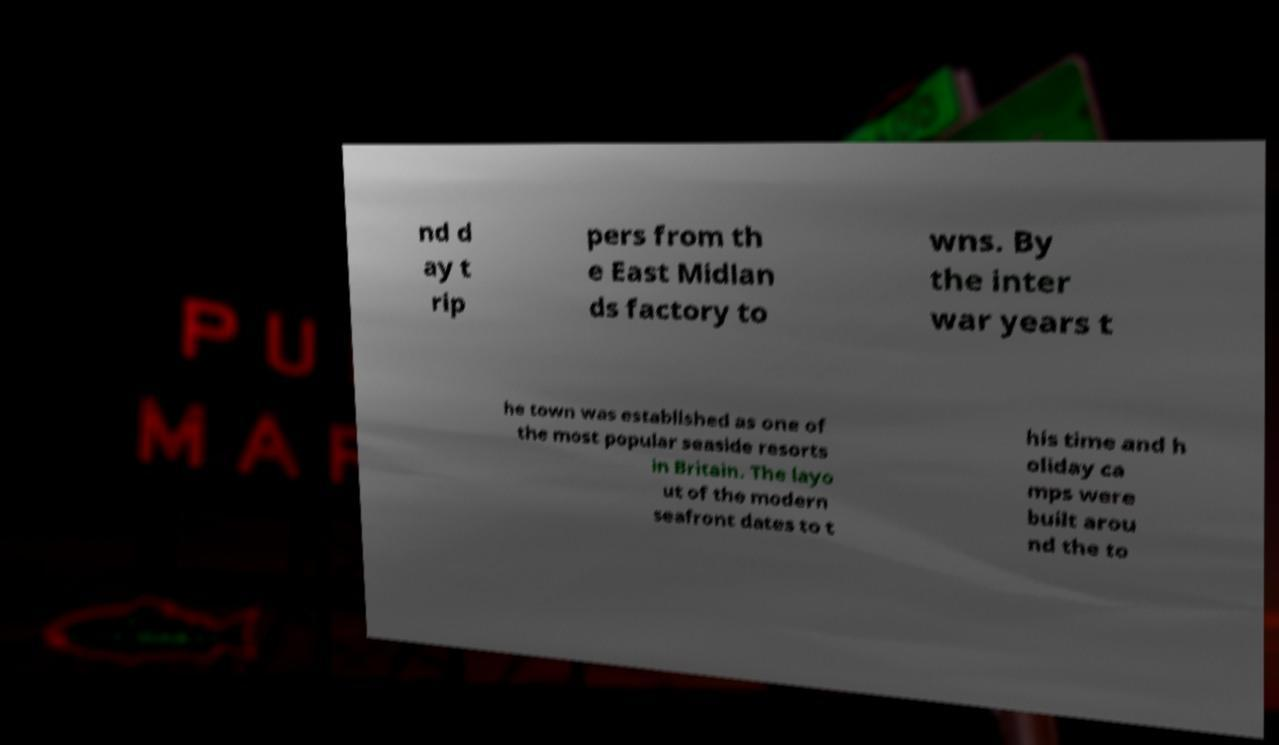Could you assist in decoding the text presented in this image and type it out clearly? nd d ay t rip pers from th e East Midlan ds factory to wns. By the inter war years t he town was established as one of the most popular seaside resorts in Britain. The layo ut of the modern seafront dates to t his time and h oliday ca mps were built arou nd the to 